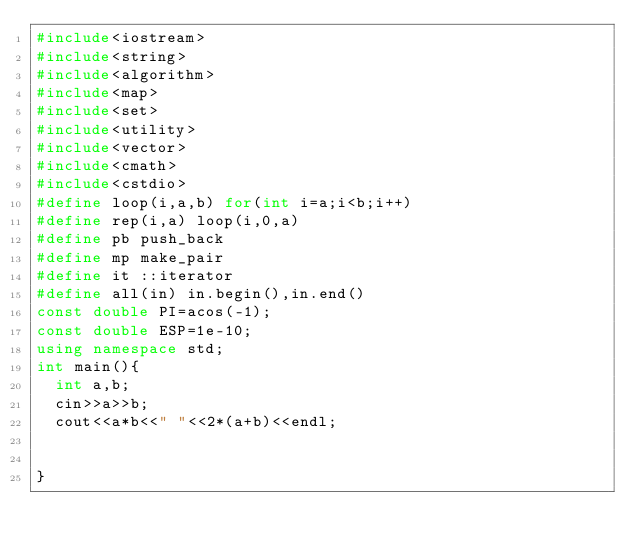<code> <loc_0><loc_0><loc_500><loc_500><_C++_>#include<iostream>
#include<string>
#include<algorithm>
#include<map>
#include<set>
#include<utility>
#include<vector>
#include<cmath>
#include<cstdio>
#define loop(i,a,b) for(int i=a;i<b;i++) 
#define rep(i,a) loop(i,0,a)
#define pb push_back
#define mp make_pair
#define it ::iterator
#define all(in) in.begin(),in.end()
const double PI=acos(-1);
const double ESP=1e-10;
using namespace std;
int main(){
  int a,b;
  cin>>a>>b;
  cout<<a*b<<" "<<2*(a+b)<<endl;


}</code> 